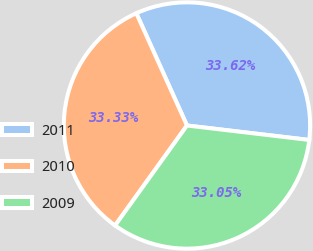Convert chart to OTSL. <chart><loc_0><loc_0><loc_500><loc_500><pie_chart><fcel>2011<fcel>2010<fcel>2009<nl><fcel>33.62%<fcel>33.33%<fcel>33.05%<nl></chart> 